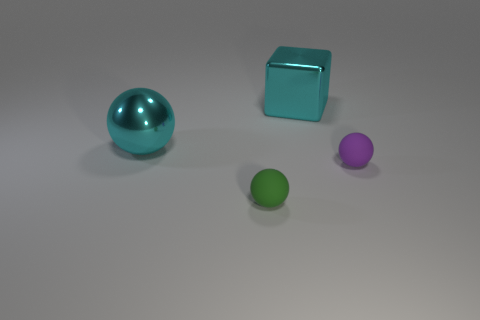What size is the shiny sphere that is the same color as the large shiny block?
Offer a very short reply. Large. Is there a metal sphere that has the same color as the block?
Make the answer very short. Yes. There is a thing that is made of the same material as the block; what is its size?
Provide a succinct answer. Large. There is a metallic object that is the same color as the cube; what shape is it?
Offer a terse response. Sphere. What shape is the object that is made of the same material as the big cube?
Give a very brief answer. Sphere. There is a rubber sphere to the left of the shiny object that is behind the big cyan shiny ball; what size is it?
Your response must be concise. Small. What number of things are tiny matte spheres that are to the left of the tiny purple sphere or tiny matte things to the right of the tiny green rubber object?
Your answer should be very brief. 2. Is the number of big things less than the number of green things?
Offer a terse response. No. How many things are either tiny red cylinders or purple balls?
Keep it short and to the point. 1. Is the shape of the purple object the same as the green object?
Your answer should be compact. Yes. 